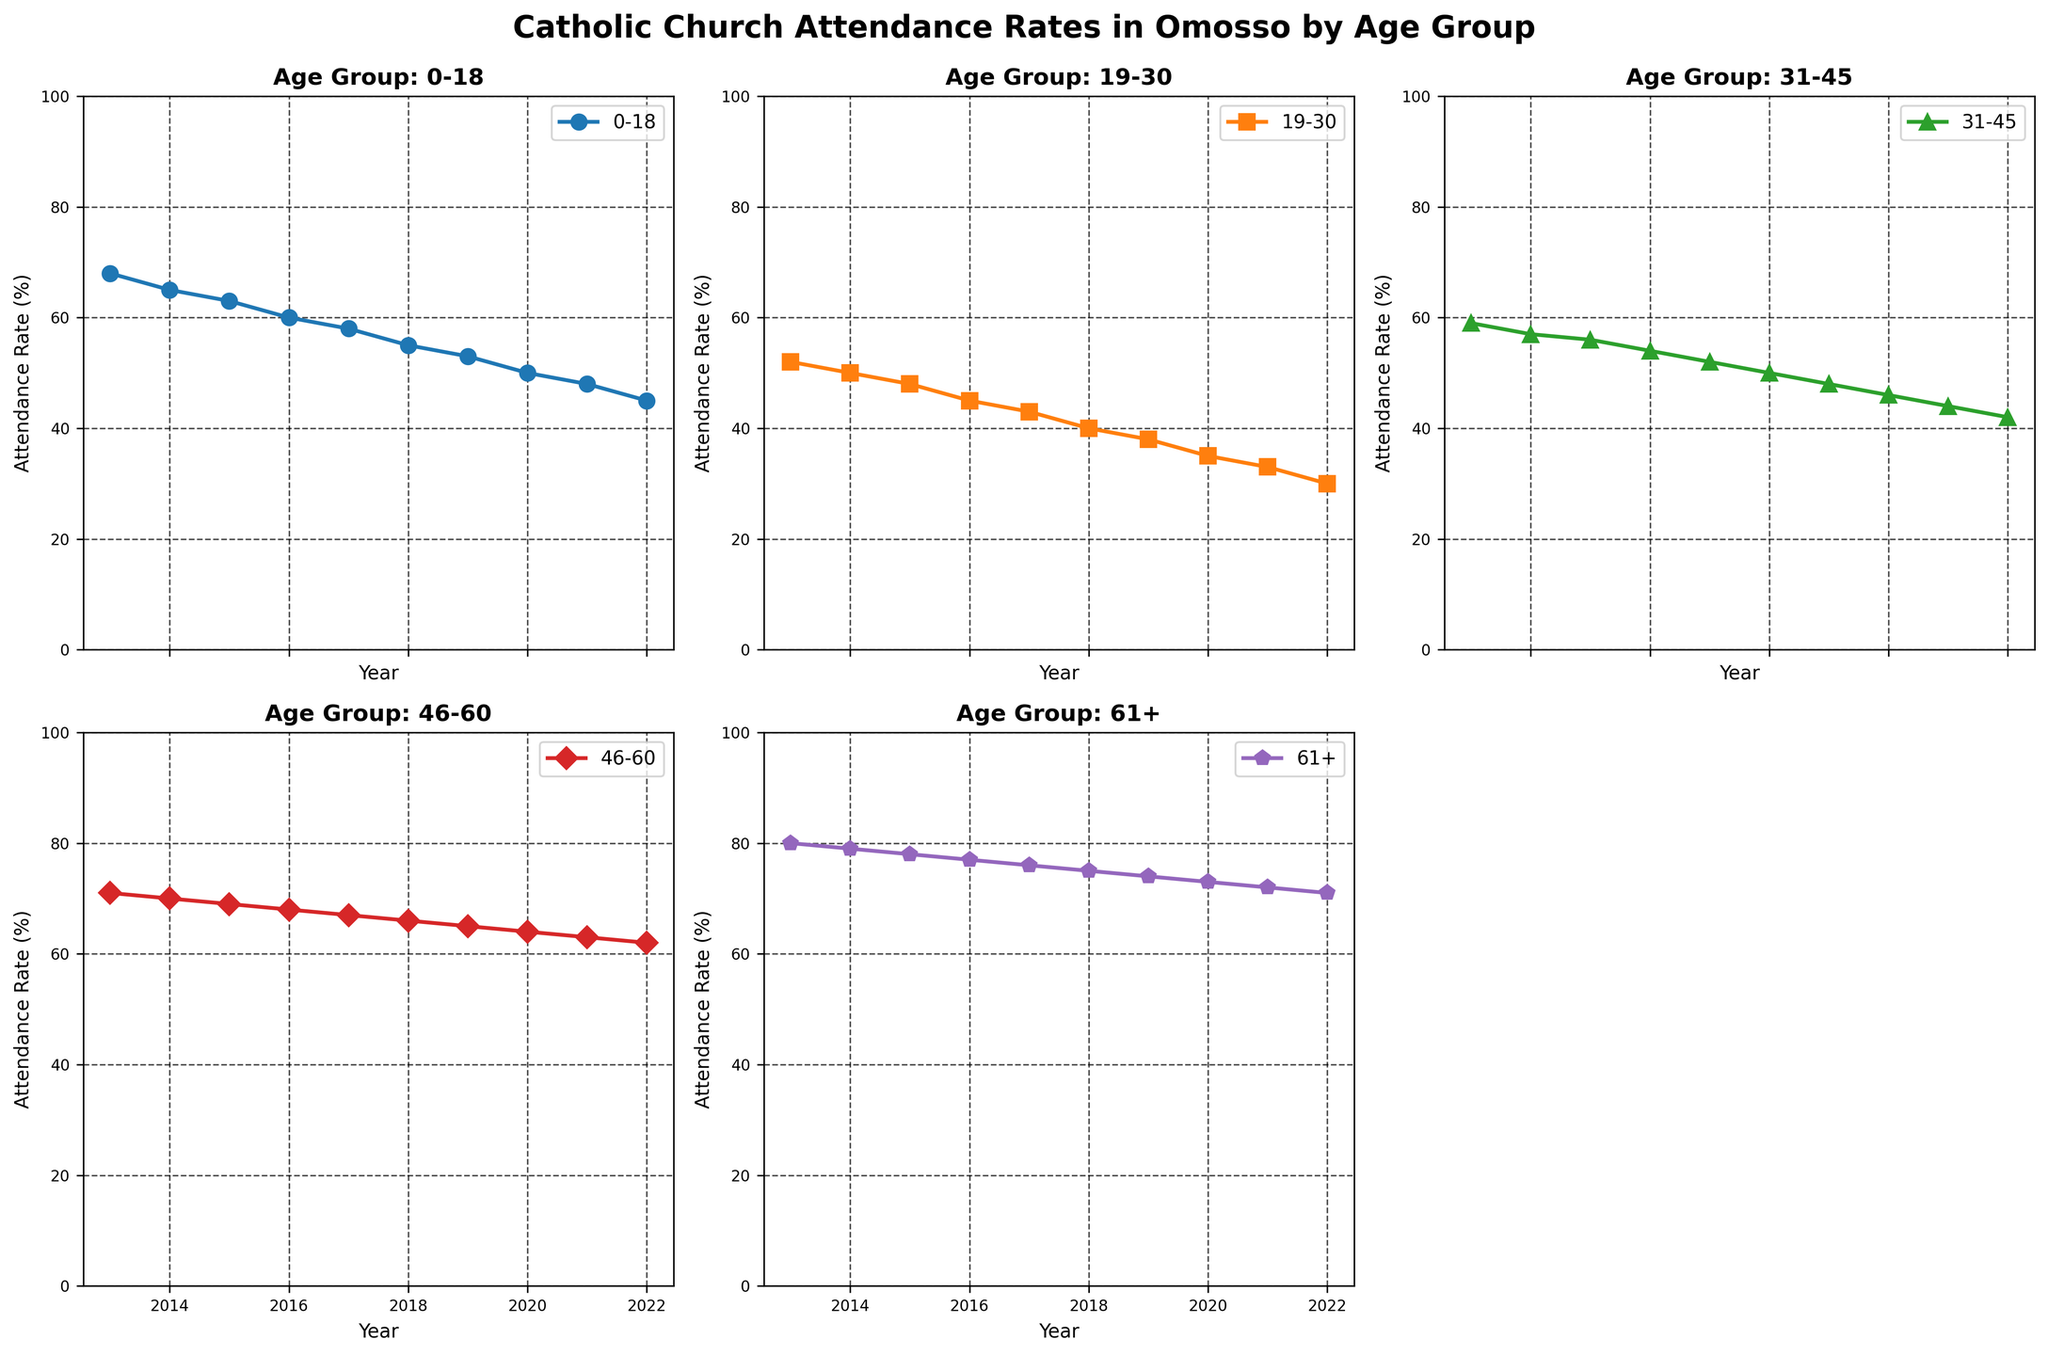what is the title of the figure? The title is found at the top center of the figure encompassing all the subplots. It gives a summary of what the plots represent.
Answer: Catholic Church Attendance Rates in Omosso by Age Group In which age group did the attendance rate decline the fastest from 2013 to 2022? To determine this, we need to compare the differences in attendance rates from 2013 to 2022 across all age groups. By subtracting the 2022 rate from the 2013 rate for each group, we find: 0-18: 68-45=23, 19-30: 52-30=22, 31-45: 59-42=17, 46-60: 71-62=9, 61+: 80-71=9. Hence, the fastest decline is in the 0-18 group.
Answer: 0-18 What was the attendance rate for the 61+ age group in 2018? Locate the subplot for the 61+ age group and check the mark or point for the year 2018. The corresponding y-value gives the attendance rate for that year.
Answer: 75% How did the attendance rate for the 46-60 age group change from 2014 to 2015? Find the 46-60 subplot and compare the attendance rates between 2014 and 2015 by subtracting the 2015 value from the 2014 value: 69-70 = -1%. This indicates a decrease.
Answer: A decrease of 1% Between which consecutive years did the 19-30 age group see the largest drop in attendance? Observe the 19-30 subplot and calculate the differences between each pair of consecutive years. The largest drop occurs between the years with the greatest absolute difference. Comparing: 52-50=2, 50-48=2, 48-45=3, 45-43=2, 43-40=3, 40-38=2, 38-35=3, 35-33=2, 33-30=3. The largest drop is 3% seen three times (2015-2016, 2017-2018, 2019-2020).
Answer: 2015-2016, 2017-2018, 2019-2020 What was the trend in attendance rates for the 0-18 age group? By examining the 0-18 subplot, we can see how the line moves over time. The line consistently slopes downward from 2013 to 2022, indicating a continuous decline in attendance rates.
Answer: Continuous decline Which age group had the highest attendance rate in 2022? Look at the subplots and locate the points for 2022 for each age group. The highest y-value among them gives the answer. The 61+ age group has a rate of 71%, which is the highest for 2022.
Answer: 61+ 